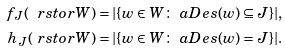Convert formula to latex. <formula><loc_0><loc_0><loc_500><loc_500>f _ { J } ( \ r s t o r { W } ) & = | \{ w \in W \colon \ a D e s ( w ) \subseteq J \} | , \\ h _ { J } ( \ r s t o r { W } ) & = | \{ w \in W \colon \ a D e s ( w ) = J \} | .</formula> 